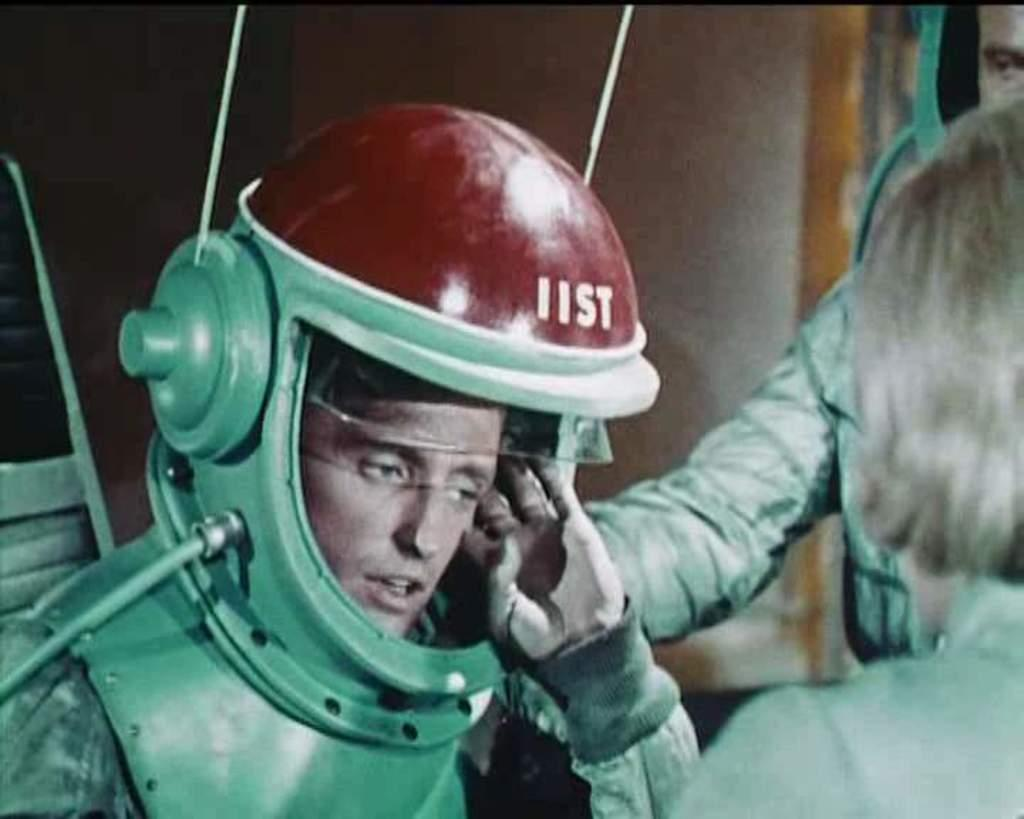What type of beings are present in the image? There are humans in the image. What protective gear are some of the humans wearing? Some of the humans are wearing helmets. What can be seen in the background of the image? There is a wall in the background of the image. What type of hammer is being used by the person in the image? There is no hammer present in the image. How many mittens can be seen on the hands of the humans in the image? There are no mittens present on the hands of the humans in the image. 